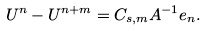Convert formula to latex. <formula><loc_0><loc_0><loc_500><loc_500>U ^ { n } - U ^ { n + m } = C _ { s , m } A ^ { - 1 } e _ { n } .</formula> 